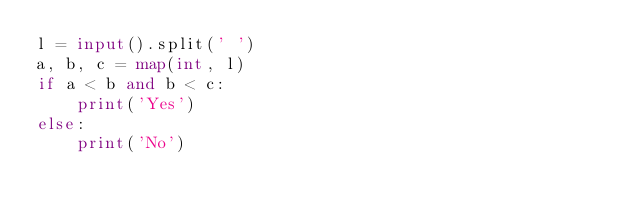Convert code to text. <code><loc_0><loc_0><loc_500><loc_500><_Python_>l = input().split(' ')
a, b, c = map(int, l)
if a < b and b < c:
    print('Yes')
else:
    print('No')
</code> 